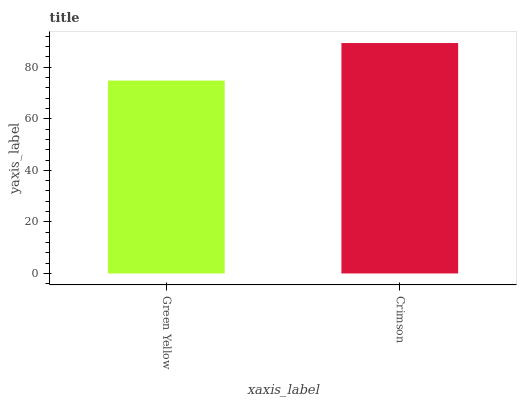Is Green Yellow the minimum?
Answer yes or no. Yes. Is Crimson the maximum?
Answer yes or no. Yes. Is Crimson the minimum?
Answer yes or no. No. Is Crimson greater than Green Yellow?
Answer yes or no. Yes. Is Green Yellow less than Crimson?
Answer yes or no. Yes. Is Green Yellow greater than Crimson?
Answer yes or no. No. Is Crimson less than Green Yellow?
Answer yes or no. No. Is Crimson the high median?
Answer yes or no. Yes. Is Green Yellow the low median?
Answer yes or no. Yes. Is Green Yellow the high median?
Answer yes or no. No. Is Crimson the low median?
Answer yes or no. No. 